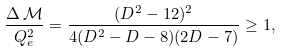<formula> <loc_0><loc_0><loc_500><loc_500>\frac { \Delta \, \mathcal { M } } { Q _ { e } ^ { 2 } } = \frac { ( D ^ { 2 } - 1 2 ) ^ { 2 } } { 4 ( D ^ { 2 } - D - 8 ) ( 2 D - 7 ) } \geq 1 ,</formula> 